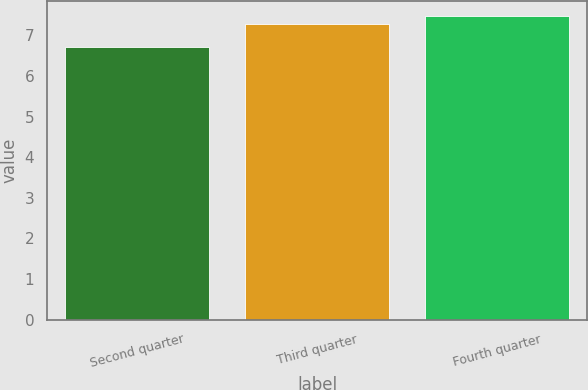Convert chart. <chart><loc_0><loc_0><loc_500><loc_500><bar_chart><fcel>Second quarter<fcel>Third quarter<fcel>Fourth quarter<nl><fcel>6.71<fcel>7.28<fcel>7.47<nl></chart> 